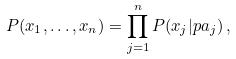<formula> <loc_0><loc_0><loc_500><loc_500>P ( x _ { 1 } , \dots , x _ { n } ) = \prod _ { j = 1 } ^ { n } P ( x _ { j } | p a _ { j } ) \, ,</formula> 